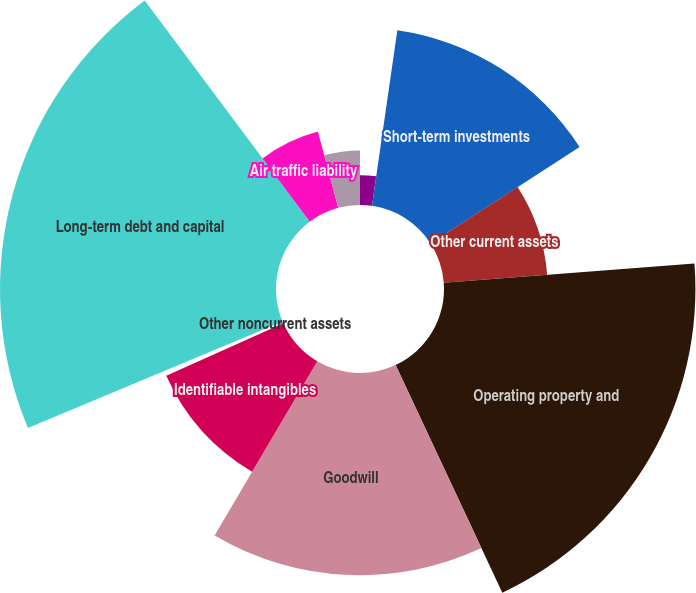Convert chart. <chart><loc_0><loc_0><loc_500><loc_500><pie_chart><fcel>Cash<fcel>Short-term investments<fcel>Other current assets<fcel>Operating property and<fcel>Goodwill<fcel>Identifiable intangibles<fcel>Other noncurrent assets<fcel>Long-term debt and capital<fcel>Air traffic liability<fcel>Loyalty program liability<nl><fcel>2.28%<fcel>13.58%<fcel>7.93%<fcel>19.23%<fcel>15.46%<fcel>9.81%<fcel>0.39%<fcel>21.11%<fcel>6.04%<fcel>4.16%<nl></chart> 